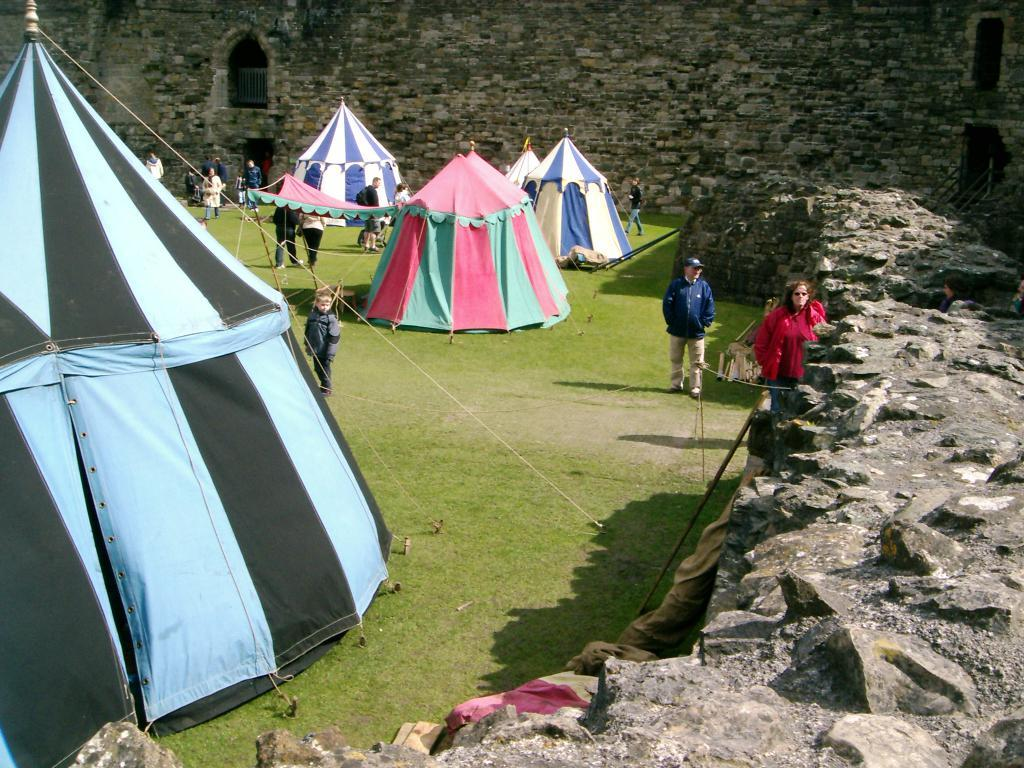What type of temporary shelters can be seen in the image? There are tents in the image. How many people are present in the image? There are many people in the image. What is the ground covered with in the image? There is grass on the ground in the image. What can be seen on the right side of the image? There is a wall with rocks on the right side of the image. What is visible in the background of the image? There is a wall with windows in the background of the image. What type of animal can be seen using its finger to point at the morning sky in the image? There is no animal or finger present in the image, and the morning sky is not visible. 